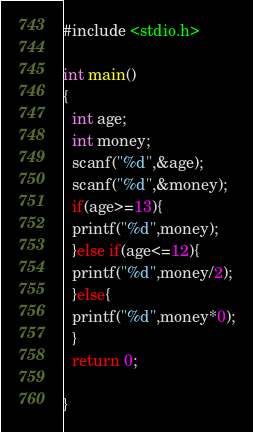<code> <loc_0><loc_0><loc_500><loc_500><_C_>#include <stdio.h>

int main()
{
  int age;
  int money;
  scanf("%d",&age);
  scanf("%d",&money);
  if(age>=13){
  printf("%d",money);
  }else if(age<=12){
  printf("%d",money/2);
  }else{
  printf("%d",money*0);
  }
  return 0;
  
}</code> 